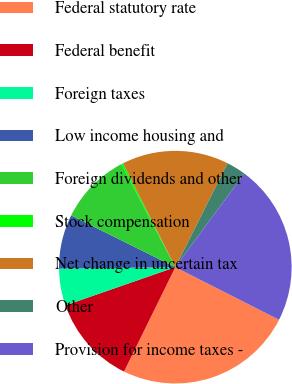Convert chart. <chart><loc_0><loc_0><loc_500><loc_500><pie_chart><fcel>Federal statutory rate<fcel>Federal benefit<fcel>Foreign taxes<fcel>Low income housing and<fcel>Foreign dividends and other<fcel>Stock compensation<fcel>Net change in uncertain tax<fcel>Other<fcel>Provision for income taxes -<nl><fcel>24.8%<fcel>12.41%<fcel>5.12%<fcel>7.55%<fcel>9.98%<fcel>0.26%<fcel>14.84%<fcel>2.69%<fcel>22.37%<nl></chart> 